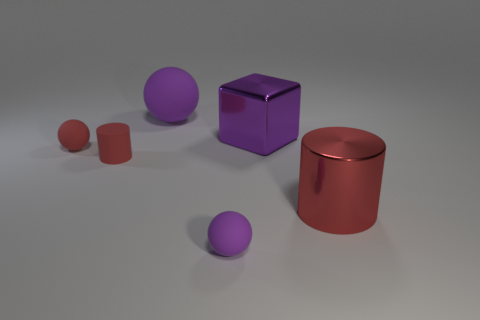Add 1 metallic things. How many objects exist? 7 Subtract all cylinders. How many objects are left? 4 Subtract 0 green spheres. How many objects are left? 6 Subtract all small yellow shiny cylinders. Subtract all tiny purple balls. How many objects are left? 5 Add 4 large rubber things. How many large rubber things are left? 5 Add 6 tiny red balls. How many tiny red balls exist? 7 